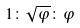Convert formula to latex. <formula><loc_0><loc_0><loc_500><loc_500>1 \colon \sqrt { \varphi } \colon \varphi</formula> 